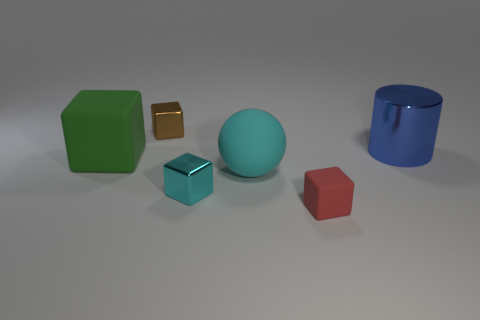Subtract all cyan cubes. How many cubes are left? 3 Add 4 metal cubes. How many objects exist? 10 Add 4 large green objects. How many large green objects are left? 5 Add 6 large green cylinders. How many large green cylinders exist? 6 Subtract all brown blocks. How many blocks are left? 3 Subtract 0 red spheres. How many objects are left? 6 Subtract all balls. How many objects are left? 5 Subtract 1 cubes. How many cubes are left? 3 Subtract all gray spheres. Subtract all yellow cubes. How many spheres are left? 1 Subtract all blue spheres. How many brown cubes are left? 1 